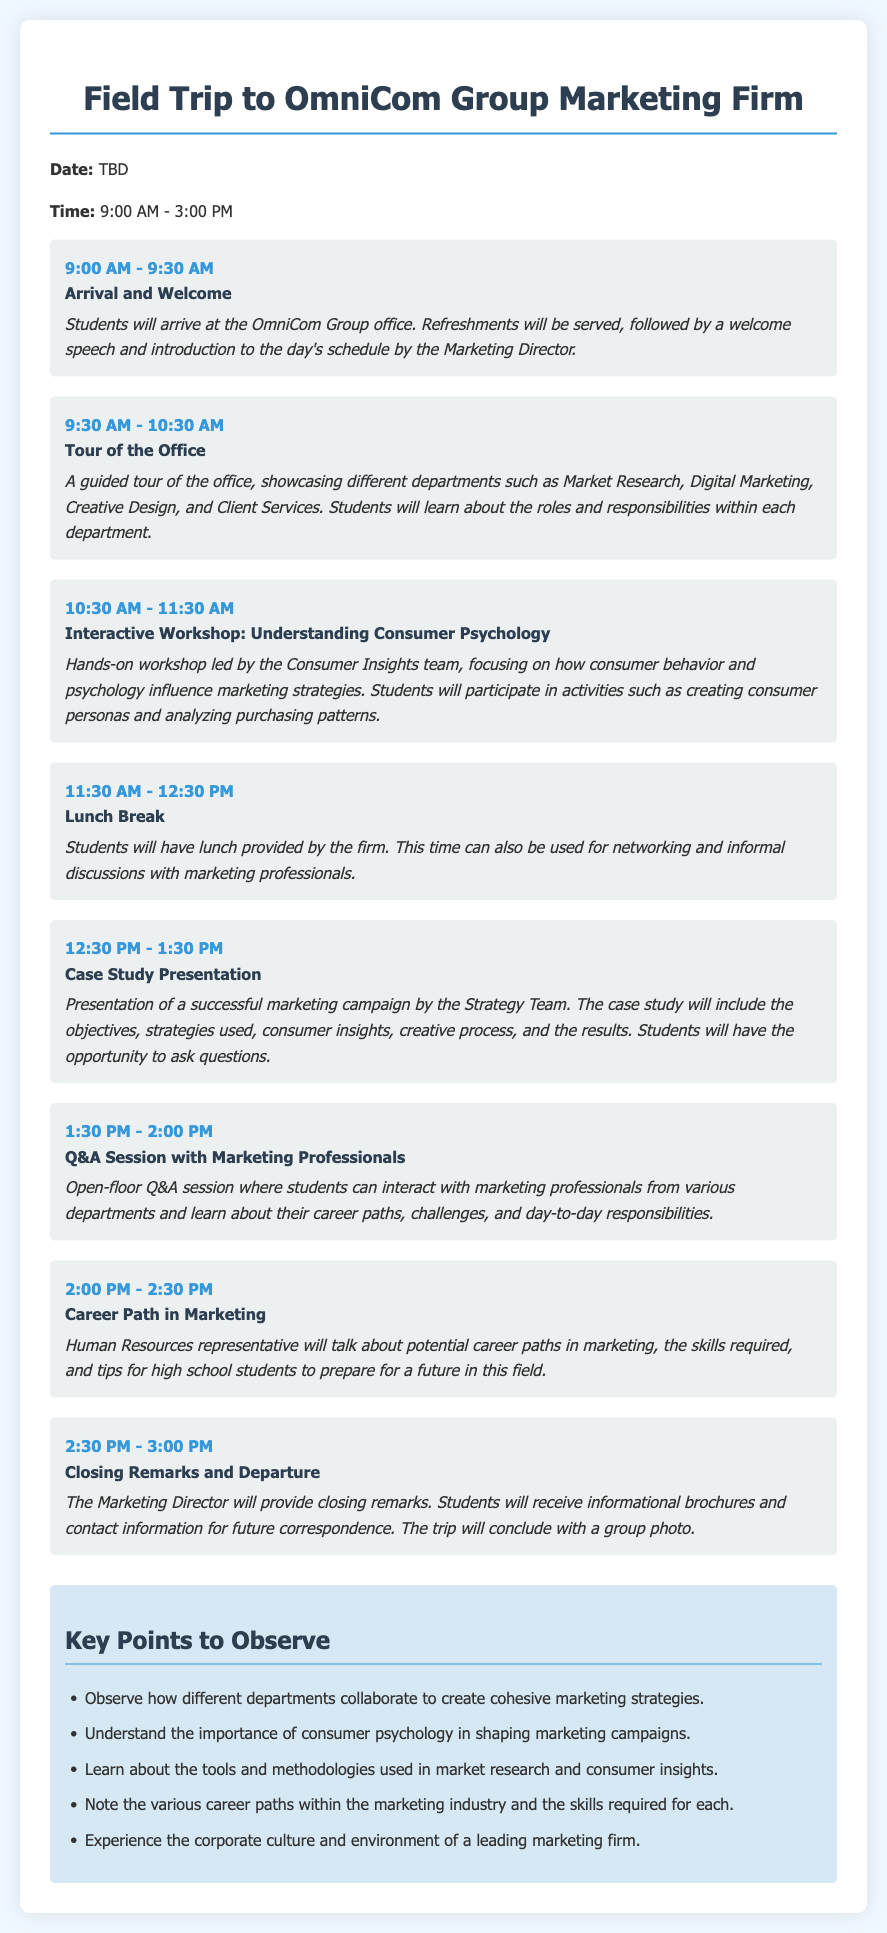what is the name of the marketing firm? The document specifies the field trip is to the OmniCom Group Marketing Firm.
Answer: OmniCom Group what time does the field trip start? The itinerary states that the field trip begins at 9:00 AM.
Answer: 9:00 AM how long is the lunch break scheduled for? According to the itinerary, the lunch break is scheduled for one hour.
Answer: 1 hour what activity follows the office tour? After the office tour, the next activity is the Interactive Workshop: Understanding Consumer Psychology.
Answer: Interactive Workshop: Understanding Consumer Psychology who will lead the Interactive Workshop? The workshop will be led by the Consumer Insights team.
Answer: Consumer Insights team what is one key point to observe during the trip? One of the key points mentioned is understanding the importance of consumer psychology in shaping marketing campaigns.
Answer: importance of consumer psychology in shaping marketing campaigns what will students receive at the end of the trip? The itinerary notes that students will receive informational brochures and contact information for future correspondence.
Answer: informational brochures who will provide the closing remarks? The document indicates that the closing remarks will be provided by the Marketing Director.
Answer: Marketing Director how many activities are scheduled before the lunch break? There are three activities scheduled before the lunch break.
Answer: 3 activities 